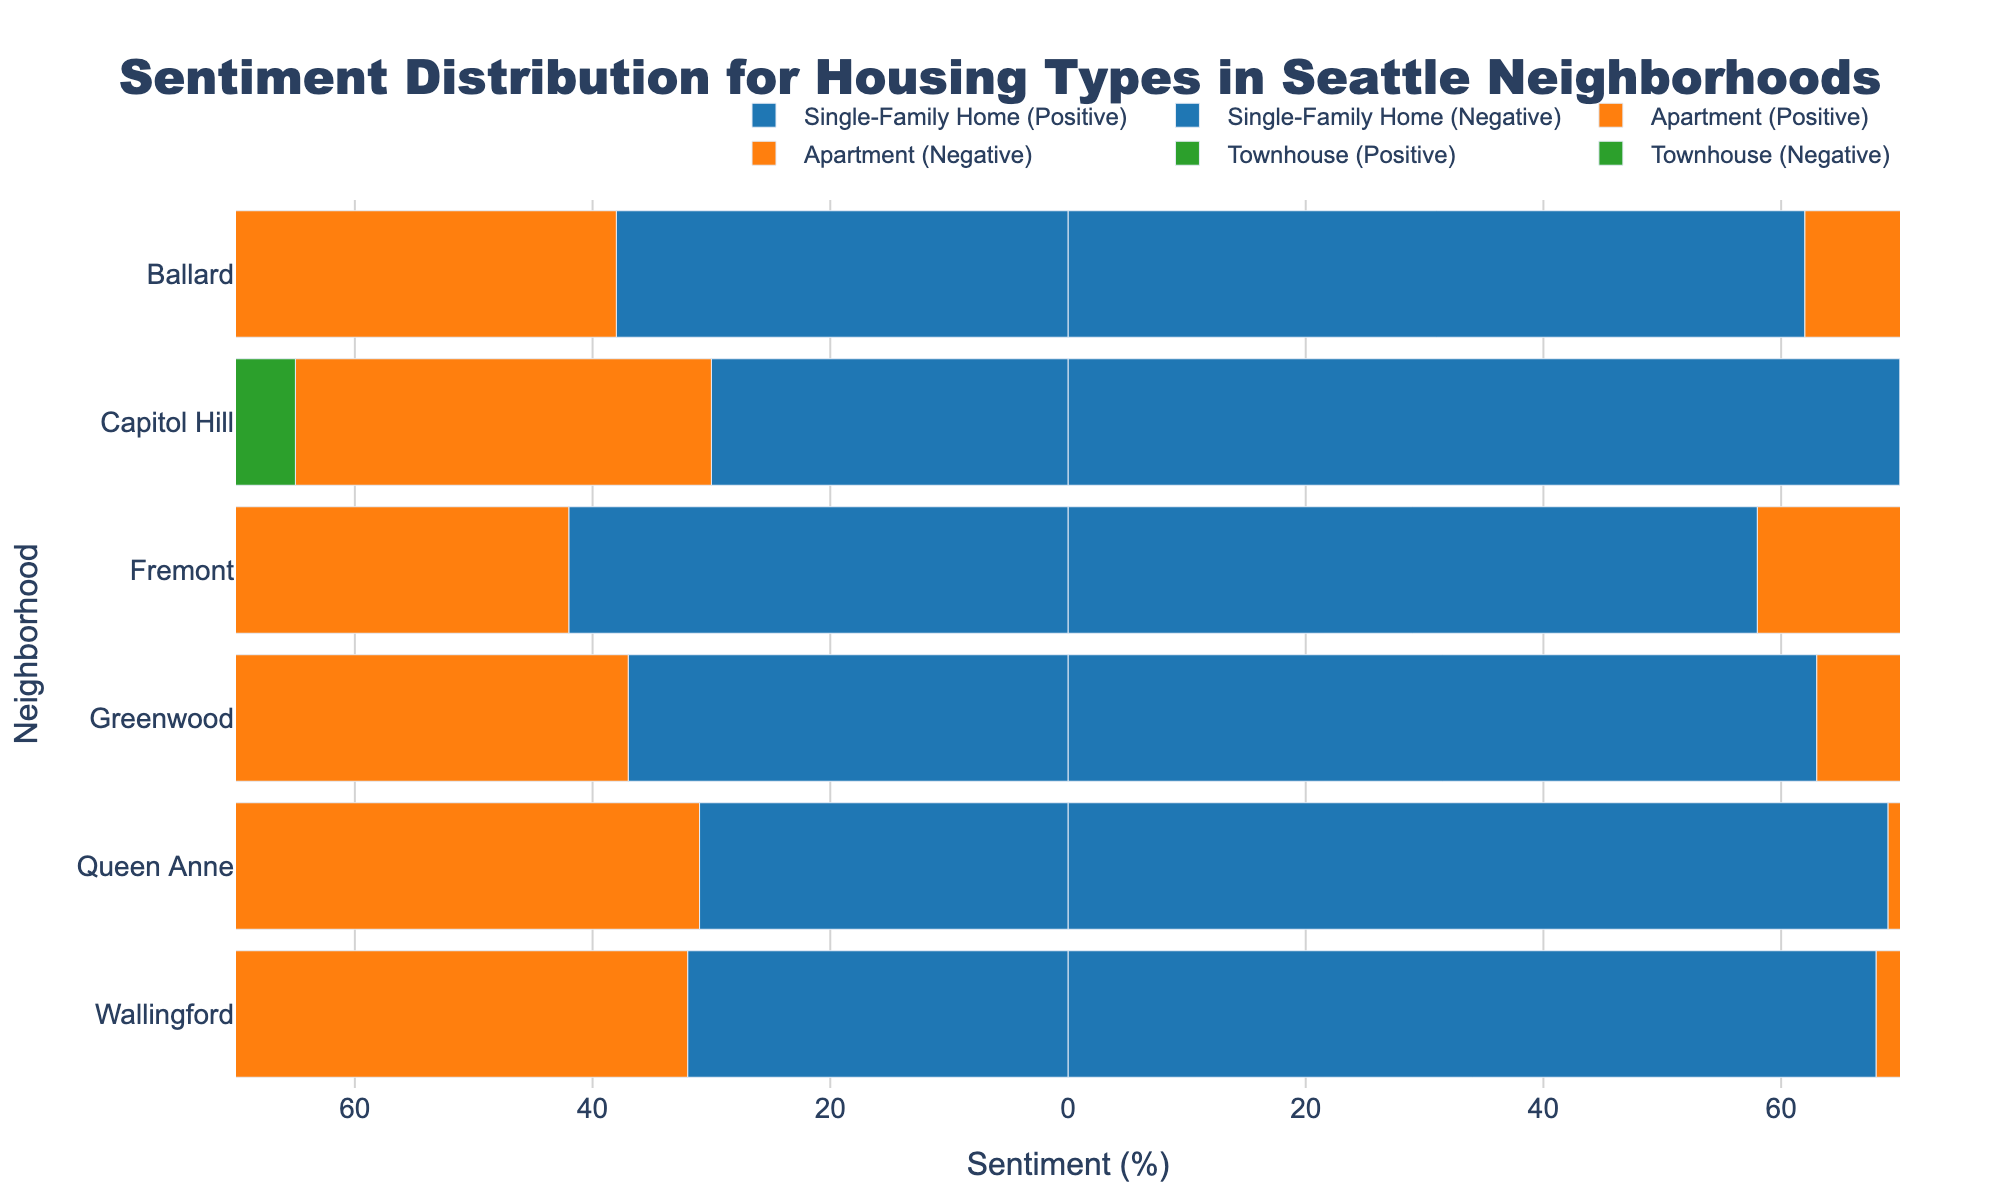What neighborhood has the highest positive sentiment for single-family homes? To determine which neighborhood has the highest positive sentiment for single-family homes, look for the tallest blue bar segment in the positive direction. From the figure, Capitol Hill has the highest positive sentiment with 70% for single-family homes.
Answer: Capitol Hill Which neighborhood has the smallest difference between positive and negative sentiments for apartments? To find the smallest difference, look for neighborhoods where the lengths of the orange bars (both positive and negative) are closest to each other. In this figure, Greenwood has an equal length of 50% for both positive and negative sentiments for apartments, making the difference 0%.
Answer: Greenwood What is the sum of positive sentiments for townhouses in Ballard and Greenwod? Add the positive sentiment percentages for townhouses in both Ballard and Greenwood. Ballard has 55% positive sentiment, and Greenwood has 52%, so the sum is 55% + 52% = 107%.
Answer: 107% In which neighborhood do apartments have a greater positive sentiment than single-family homes? Compare the lengths of orange bars for positive sentiments of apartments and blue bars for single-family homes for each neighborhood. In the figure, Capitol Hill is the only neighborhood where the positive sentiment for apartments (65%) is greater than for single-family homes (70%).
Answer: Capitol Hill Which housing type generally has lower negative sentiments across all neighborhoods? Examine the lengths of the negative sentiment bars (leftward direction) for each housing type across all neighborhoods. Single-family homes (blue) have consistently shorter negative sentiment bars compared to apartments (orange) and townhouses (green).
Answer: Single-family homes For Queen Anne, compare the positive sentiments across all housing types and identify the highest one. Evaluate the lengths of the bars in the positive direction for Queen Anne. Single-family homes have a positive sentiment of 69%, apartments have 60%, and townhouses have 65%. So, single-family homes have the highest positive sentiment in Queen Anne.
Answer: Single-family homes What is the average positive sentiment for single-family homes in Fremont and Wallingford? Add the positive sentiment percentages for single-family homes in Fremont and Wallingford and then divide by 2. Fremont has 58% positive sentiment and Wallingford has 68%, so the average is (58% + 68%) / 2 = 63%.
Answer: 63% Which neighborhood shows more negative sentiment for townhouses: Ballard or Capitol Hill? Compare the lengths of the green bars for negative sentiments of townhouses in Ballard (45%) and Capitol Hill (40%). Ballard has a higher negative sentiment compared to Capitol Hill.
Answer: Ballard 